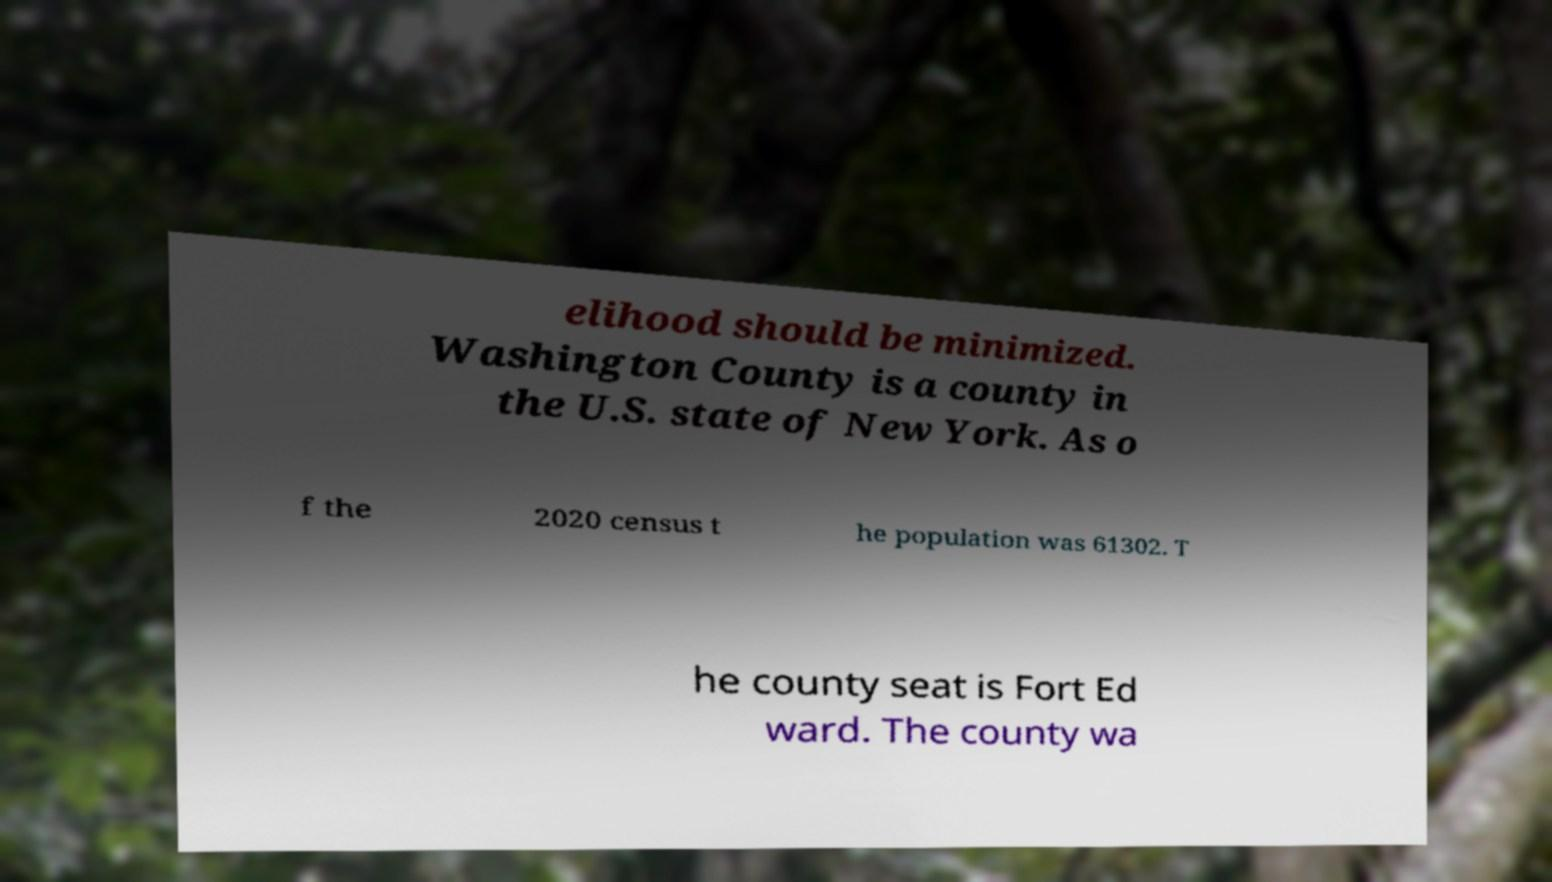Could you extract and type out the text from this image? elihood should be minimized. Washington County is a county in the U.S. state of New York. As o f the 2020 census t he population was 61302. T he county seat is Fort Ed ward. The county wa 